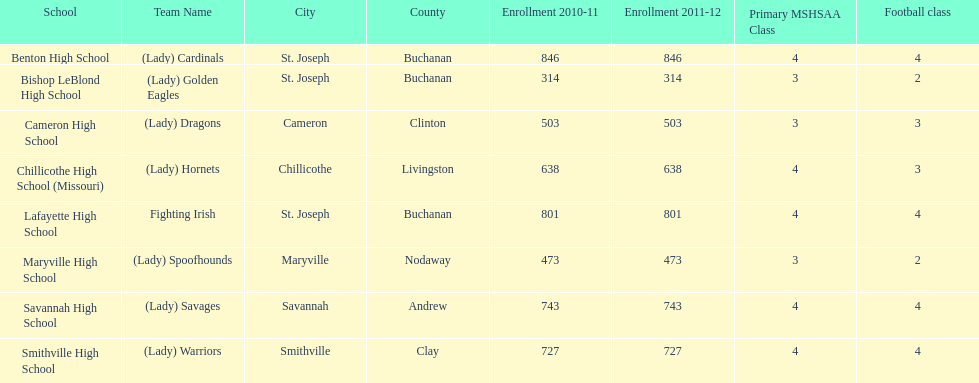Which schools are in the same town as bishop leblond? Benton High School, Lafayette High School. 